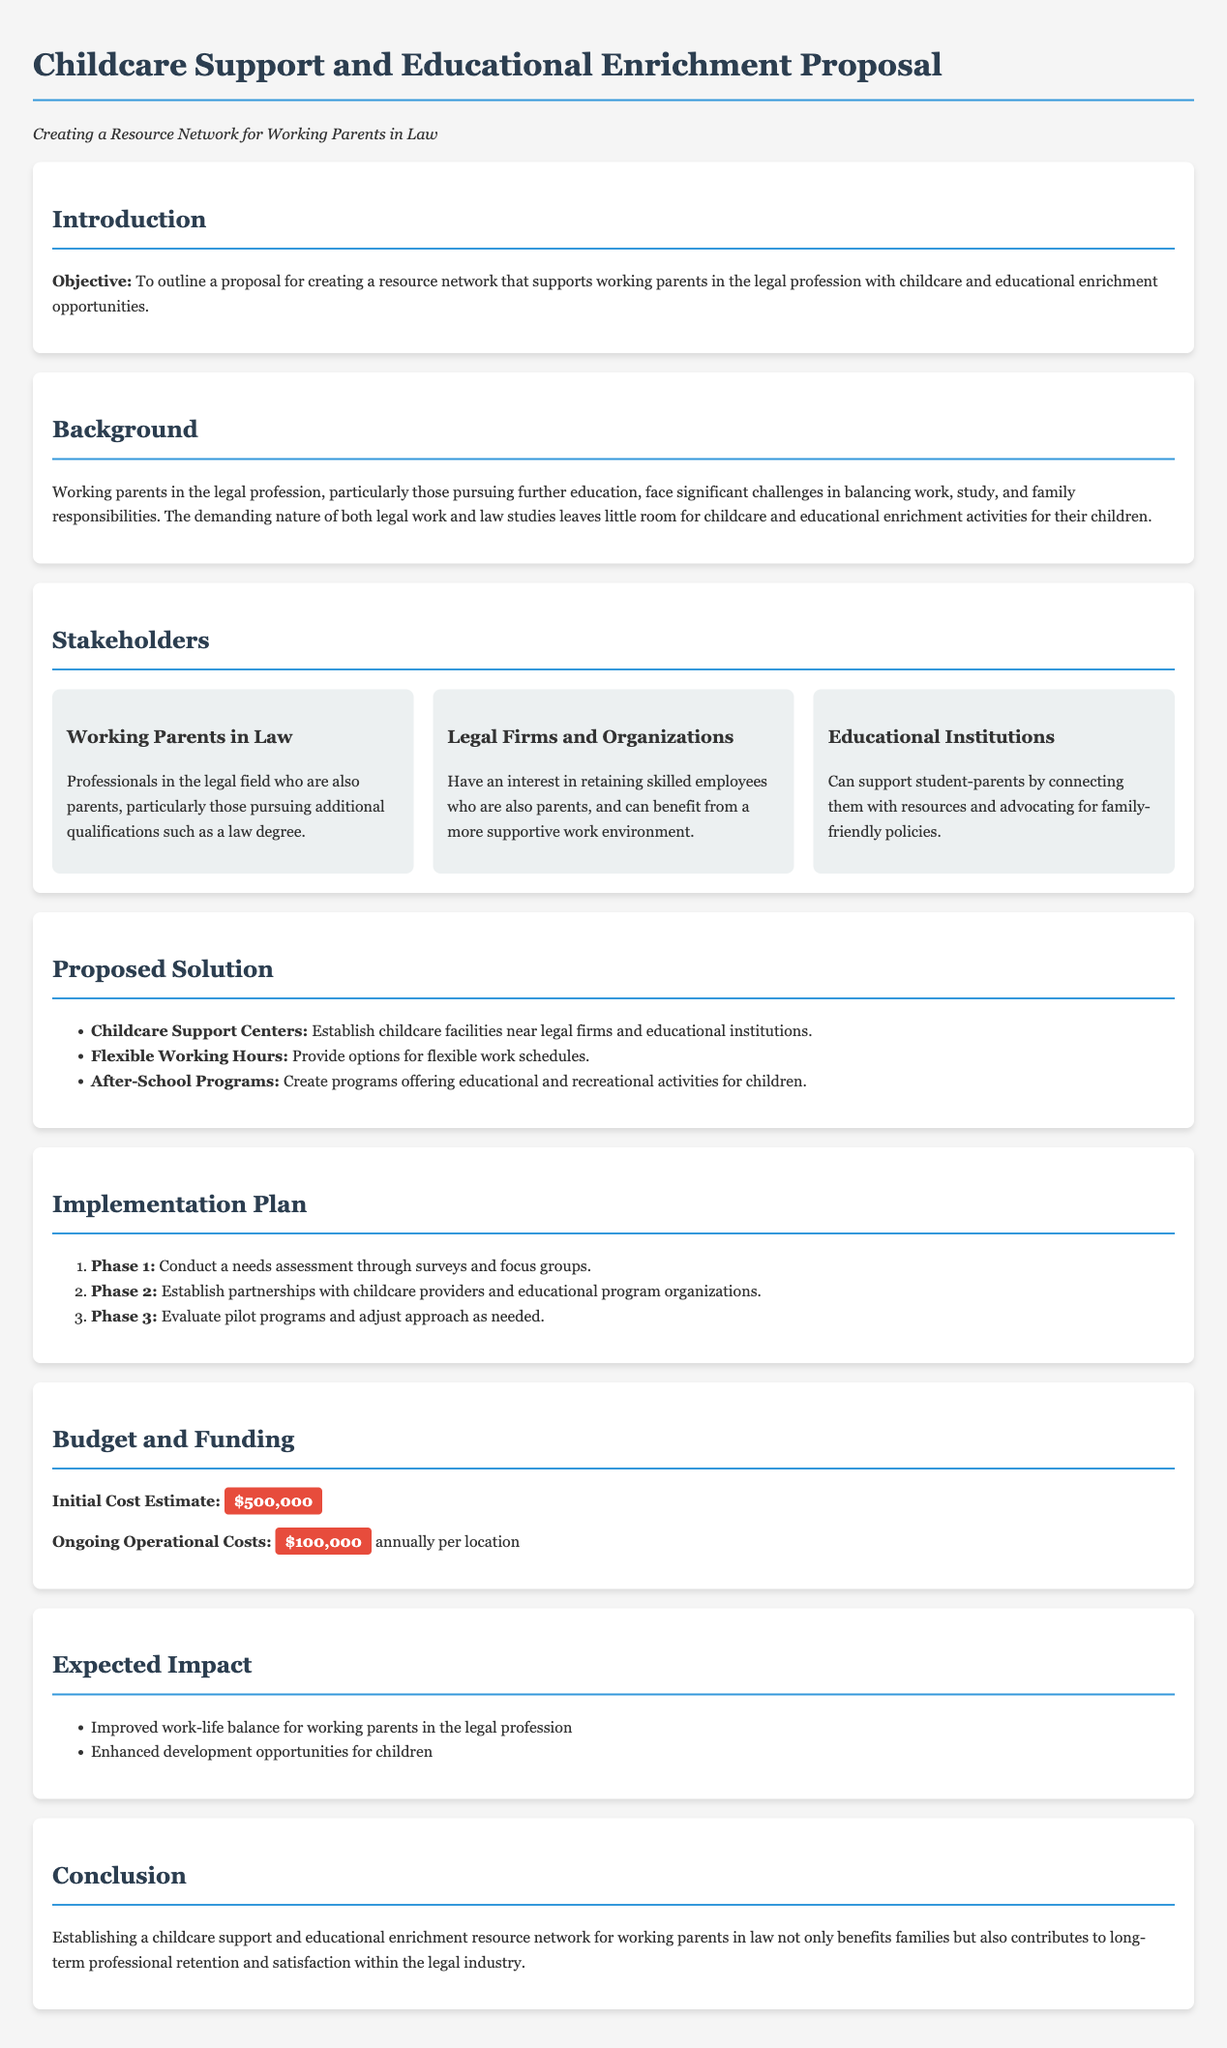What is the objective of the proposal? The objective is to outline a proposal for creating a resource network that supports working parents in the legal profession with childcare and educational enrichment opportunities.
Answer: To support working parents in the legal profession What is the initial cost estimate? The initial cost estimate is stated in the budget section as the overall financial requirement to start the project.
Answer: $500,000 What type of support does the proposed solution offer? The proposed solution includes various components designed to assist working parents in balancing their responsibilities.
Answer: Childcare Support Centers How many phases are in the implementation plan? The implementation plan lists distinct steps to execute the proposal, indicating its structured approach.
Answer: 3 Who are the primary stakeholders mentioned in the proposal? The stakeholders are identified as critical groups involved in the execution of the proposal, showcasing diverse interests.
Answer: Working Parents in Law What is one expected impact of the proposal? The expected impacts of the proposal reflect the potential benefits it offers to the targeted community.
Answer: Improved work-life balance What is the ongoing operational cost per location? This cost represents the financial resources needed to sustain the childcare support and educational enrichment facilities annually.
Answer: $100,000 What is a key challenge faced by working parents in law? The proposal addresses specific difficulties experienced by parents in the legal profession, highlighting their unique situation.
Answer: Balancing work, study, and family responsibilities What are the flexible working options mentioned in the proposed solution? The proposal suggests certain employment practices aimed at accommodating parents' schedules to ease their burden.
Answer: Flexible Working Hours 